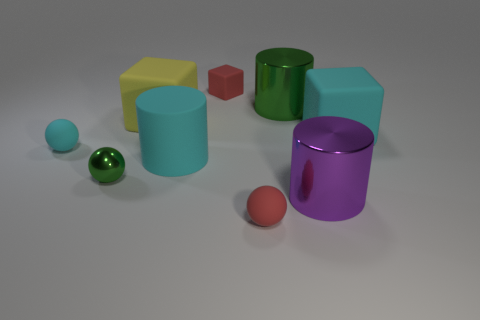Subtract all cyan matte blocks. How many blocks are left? 2 Subtract all cyan spheres. How many spheres are left? 2 Subtract 2 blocks. How many blocks are left? 1 Subtract all cylinders. How many objects are left? 6 Subtract all cyan blocks. How many red balls are left? 1 Add 1 red blocks. How many objects exist? 10 Subtract 0 brown cubes. How many objects are left? 9 Subtract all brown blocks. Subtract all yellow balls. How many blocks are left? 3 Subtract all big cyan things. Subtract all cyan things. How many objects are left? 4 Add 8 tiny cyan matte spheres. How many tiny cyan matte spheres are left? 9 